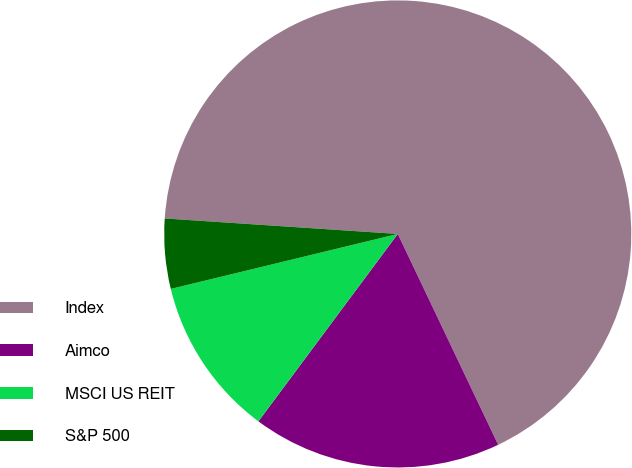Convert chart to OTSL. <chart><loc_0><loc_0><loc_500><loc_500><pie_chart><fcel>Index<fcel>Aimco<fcel>MSCI US REIT<fcel>S&P 500<nl><fcel>66.87%<fcel>17.25%<fcel>11.04%<fcel>4.84%<nl></chart> 